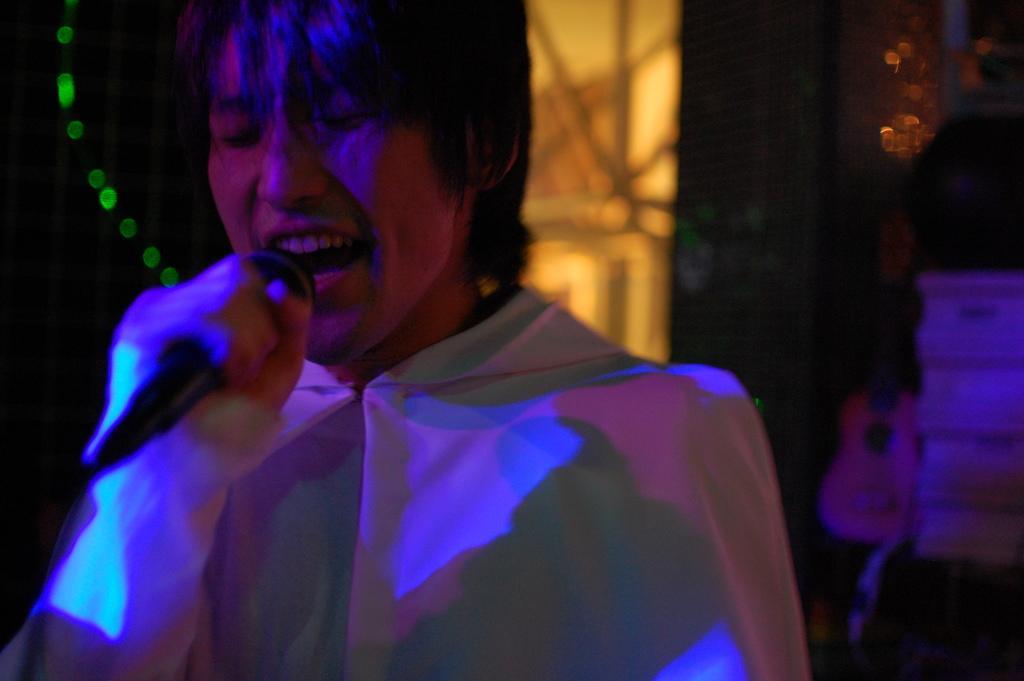Describe this image in one or two sentences. In this picture we can see a person holding a mic and singing and in the background we can see lights, guitar and it is dark. 